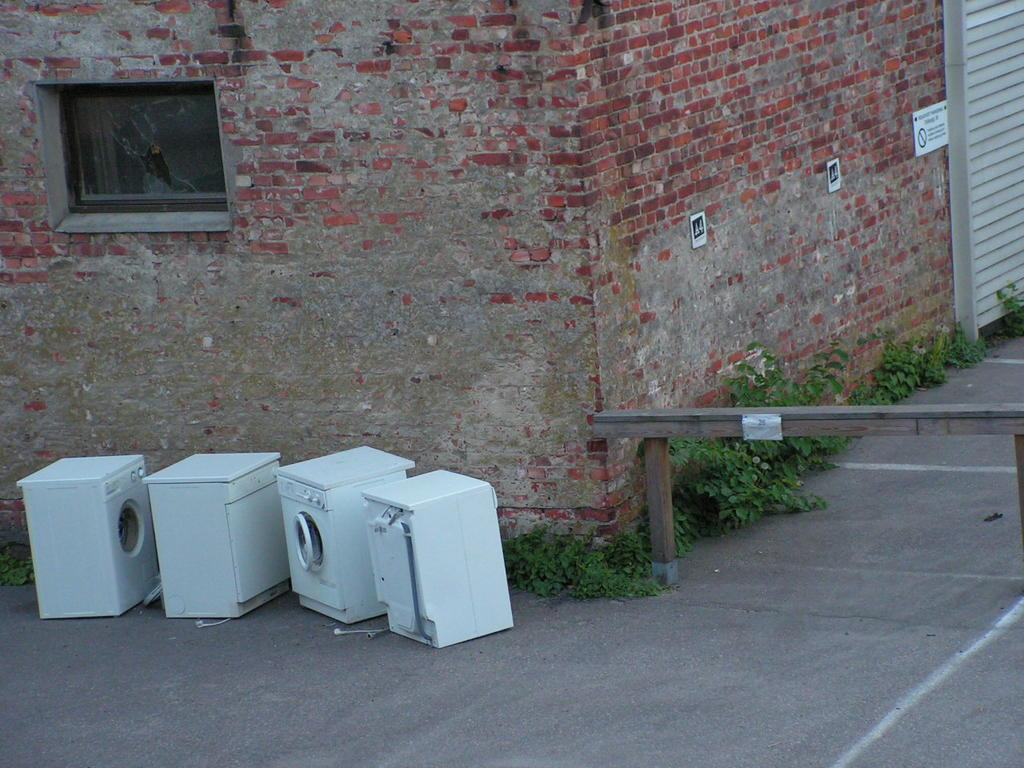What type of appliances can be seen on the path in the image? There are washing machines on the path in the image. What type of natural elements are present in the image? There are plants in the image. What type of material is used for the wooden object in the image? There is a wooden object in the image, but the specific material is not mentioned. What type of structure can be seen in the image? There are brick walls in the image. What type of signage or display is present in the image? There are boards in the image. What type of transparent barrier is present in the image? There is a glass window in the image. What type of movable barrier is present in the image? There is a shutter in the image. What type of transportation route is visible in the image? There is a road in the image. How many cents are visible on the washing machines in the image? There are no cents visible on the washing machines in the image. What type of destruction can be seen in the image? There is no destruction present in the image. What type of weather condition is depicted in the image? The image does not depict any specific weather condition, such as a rainstorm. 